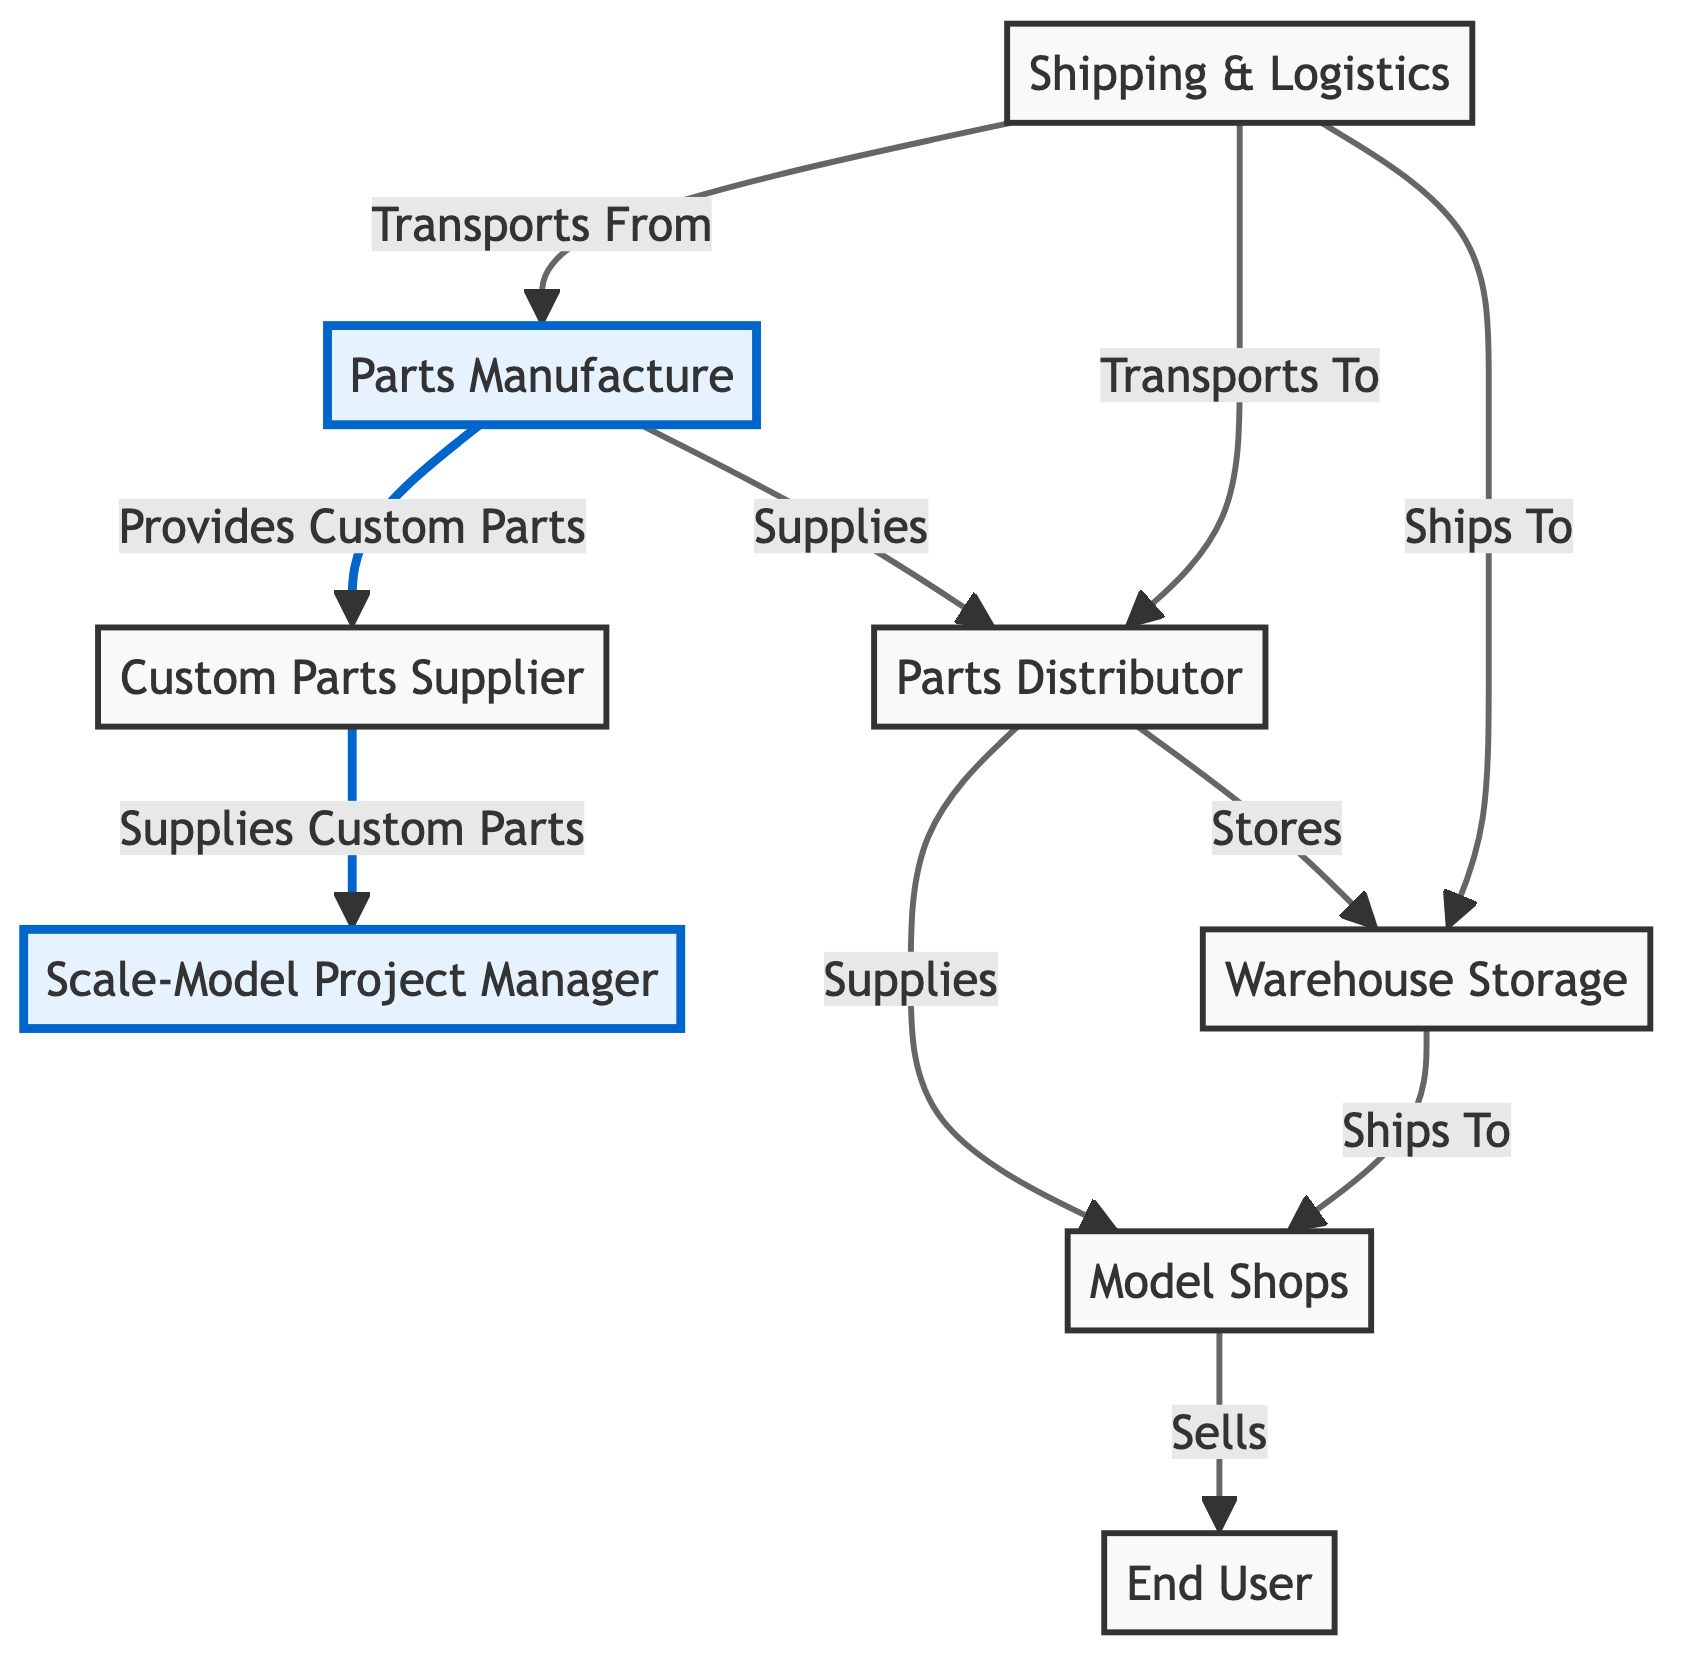What is the initial node in the supply chain? The initial node in the supply chain is the "Parts Manufacture" node, where scale-model parts are produced before moving to other entities in the network.
Answer: Parts Manufacture How many nodes are present in the diagram? By counting all unique entities represented in the diagram, we find a total of 8 nodes, including manufacturer, distributor, retailer, logistics provider, project manager, warehouse, customer, and custom parts supplier.
Answer: 8 Which entity sells directly to the customer? The "Model Shops," represented as the Retailer node, is the entity that sells scale-model parts directly to consumers in the supply chain process.
Answer: Model Shops How many edges connect the Manufacturer to other nodes? The Manufacturer node is connected to three edges: one to Distributor, one to Custom Parts Supplier, and one from Logistics Provider, totaling three connections.
Answer: 3 What is the relationship between the Distributor and Retailer? The relationship is defined as "Supplies," indicating that the Distributor provides parts to the Retailer within the supply chain.
Answer: Supplies Which node does the Custom Parts Supplier supply directly to? The Custom Parts Supplier supplies directly to the Scale-Model Project Manager, as indicated by the edge labeled "Supplies Custom Parts."
Answer: Scale-Model Project Manager What is the function of the Logistics Provider in this network? The Logistics Provider's function is to transport parts from manufacturers and distributors, as well as to ship to warehouses, facilitating the movement within the supply chain.
Answer: Shipping & Logistics What role does the Warehouse play in this supply chain diagram? The Warehouse serves the role of storing parts supplied from distributors and shipping them to retailers, acting as an intermediary storage facility in the supply chain.
Answer: Warehouse Storage Which node receives custom parts from the Custom Parts Supplier? The "Scale-Model Project Manager" receives custom parts from the Custom Parts Supplier, as shown by the directed edge labeled "Supplies Custom Parts."
Answer: Scale-Model Project Manager 